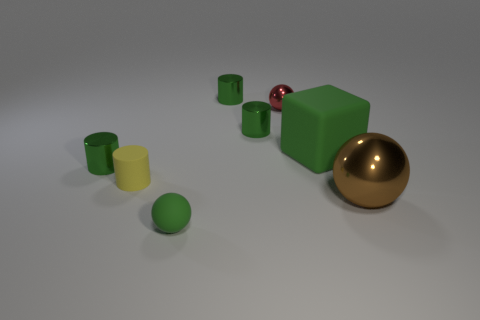Are there the same number of small cylinders to the right of the green rubber sphere and green cylinders behind the block?
Keep it short and to the point. Yes. How many other things are made of the same material as the small yellow thing?
Offer a terse response. 2. Are there the same number of large brown objects in front of the small metallic ball and small yellow cylinders?
Your answer should be very brief. Yes. Does the red metallic thing have the same size as the green rubber object that is in front of the yellow thing?
Offer a very short reply. Yes. What shape is the small metallic thing behind the small red metal ball?
Make the answer very short. Cylinder. Are there any other things that have the same shape as the tiny yellow object?
Your answer should be very brief. Yes. Are any big yellow rubber spheres visible?
Make the answer very short. No. There is a green rubber thing that is in front of the big metallic ball; does it have the same size as the metallic sphere in front of the yellow thing?
Provide a succinct answer. No. What material is the object that is both in front of the tiny yellow rubber cylinder and on the left side of the large cube?
Provide a short and direct response. Rubber. There is a green ball; how many rubber things are left of it?
Your answer should be very brief. 1. 